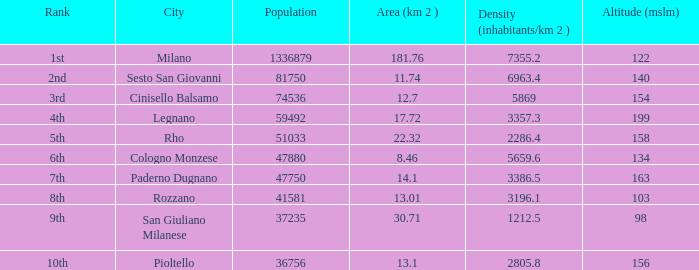Which Population has an Altitude (mslm) larger than 98, and a Density (inhabitants/km 2) larger than 5869, and a Rank of 1st? 1336879.0. 